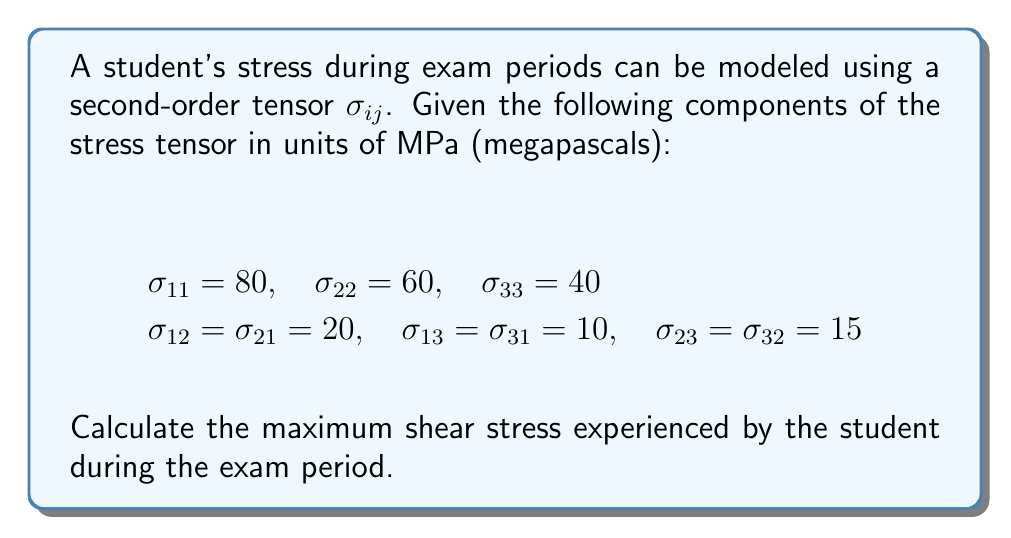Could you help me with this problem? To find the maximum shear stress, we need to follow these steps:

1) First, we need to construct the stress tensor:

   $$\sigma_{ij} = \begin{bmatrix}
   80 & 20 & 10 \\
   20 & 60 & 15 \\
   10 & 15 & 40
   \end{bmatrix}$$

2) Calculate the principal stresses by finding the eigenvalues of the stress tensor. This involves solving the characteristic equation:

   $$det(\sigma_{ij} - \lambda I) = 0$$

   where $I$ is the identity matrix and $\lambda$ are the eigenvalues.

3) Expanding the determinant gives us the characteristic equation:

   $$-\lambda^3 + 180\lambda^2 - 9775\lambda + 156000 = 0$$

4) Solving this equation (which can be done numerically) gives us the principal stresses:

   $$\sigma_1 \approx 89.54 \text{ MPa}$$
   $$\sigma_2 \approx 61.95 \text{ MPa}$$
   $$\sigma_3 \approx 28.51 \text{ MPa}$$

5) The maximum shear stress is given by the formula:

   $$\tau_{max} = \frac{\sigma_1 - \sigma_3}{2}$$

6) Substituting the values:

   $$\tau_{max} = \frac{89.54 - 28.51}{2} = 30.515 \text{ MPa}$$

This represents the maximum shear stress experienced by the student during the exam period.
Answer: $\tau_{max} \approx 30.52 \text{ MPa}$ 